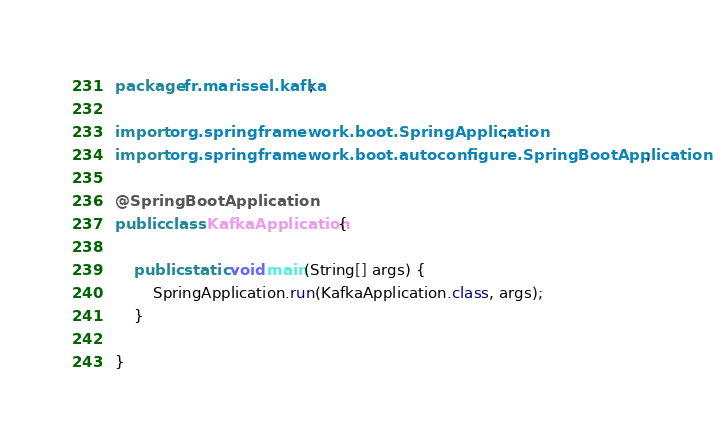<code> <loc_0><loc_0><loc_500><loc_500><_Java_>package fr.marissel.kafka;

import org.springframework.boot.SpringApplication;
import org.springframework.boot.autoconfigure.SpringBootApplication;

@SpringBootApplication
public class KafkaApplication {

	public static void main(String[] args) {
		SpringApplication.run(KafkaApplication.class, args);
	}

}
</code> 